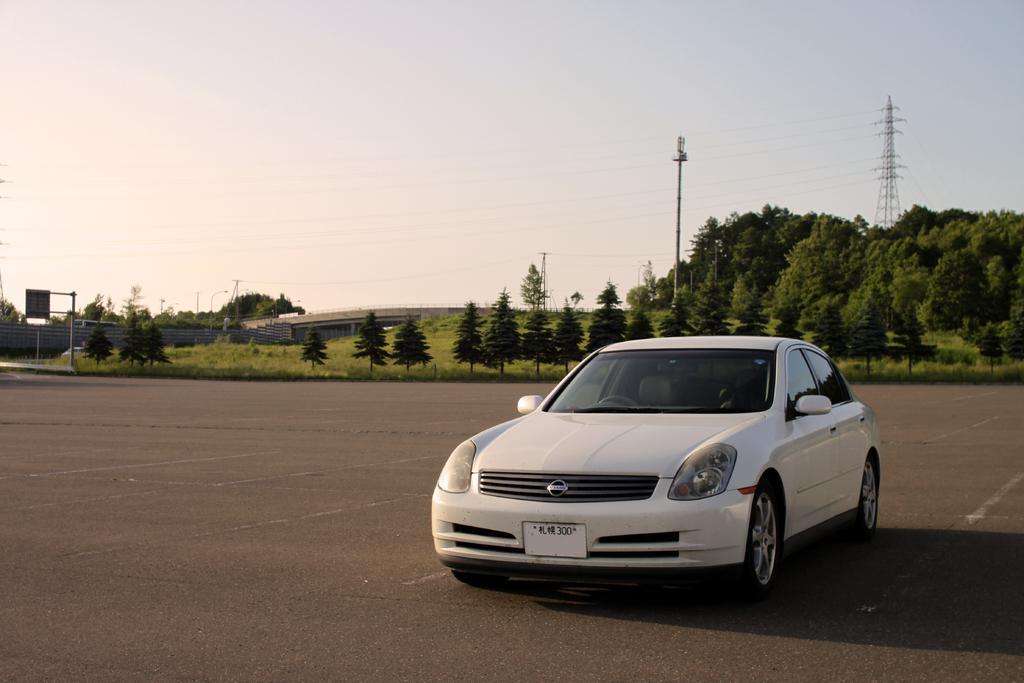Could you give a brief overview of what you see in this image? In this picture we can see a white car on the road. There are few trees, poles, tower and some wires are visible in the background. There is a building, compound wall and a board on the pole on the left side. 